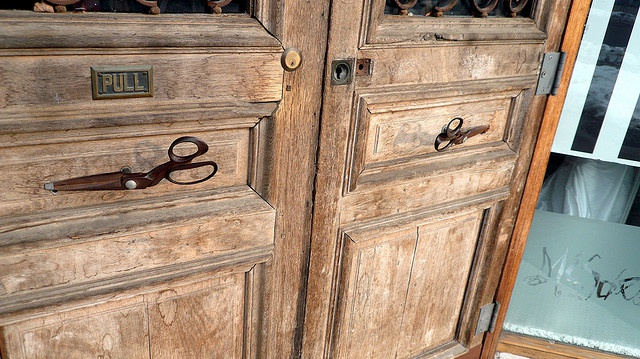Describe the objects in this image and their specific colors. I can see scissors in black, maroon, and tan tones and scissors in black, gray, and maroon tones in this image. 